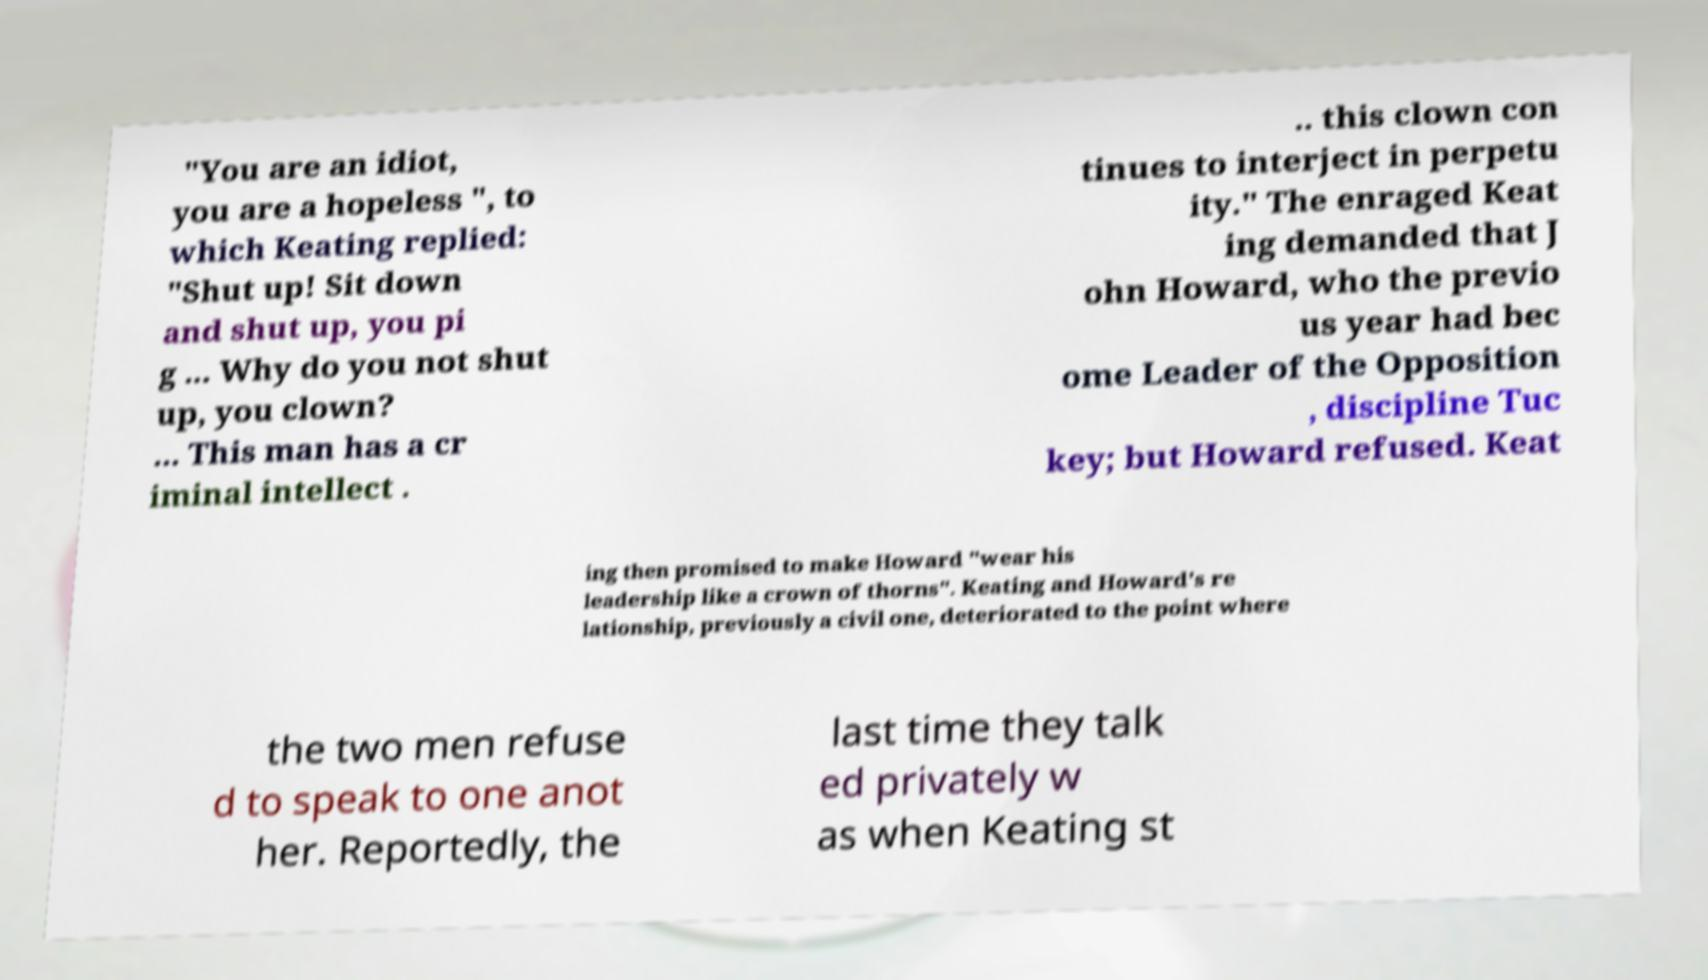There's text embedded in this image that I need extracted. Can you transcribe it verbatim? "You are an idiot, you are a hopeless ", to which Keating replied: "Shut up! Sit down and shut up, you pi g ... Why do you not shut up, you clown? ... This man has a cr iminal intellect . .. this clown con tinues to interject in perpetu ity." The enraged Keat ing demanded that J ohn Howard, who the previo us year had bec ome Leader of the Opposition , discipline Tuc key; but Howard refused. Keat ing then promised to make Howard "wear his leadership like a crown of thorns". Keating and Howard's re lationship, previously a civil one, deteriorated to the point where the two men refuse d to speak to one anot her. Reportedly, the last time they talk ed privately w as when Keating st 